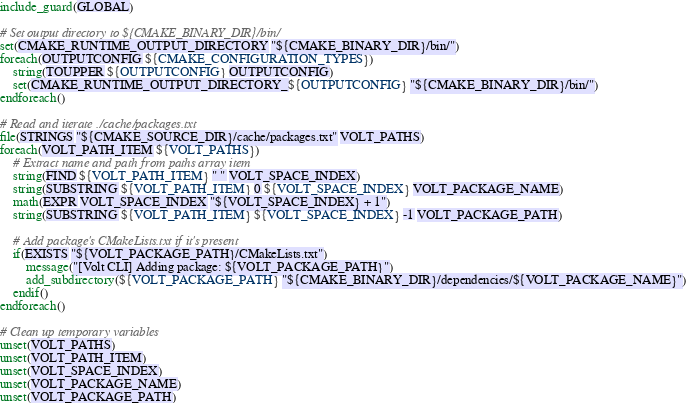<code> <loc_0><loc_0><loc_500><loc_500><_CMake_>include_guard(GLOBAL)

# Set output directory to ${CMAKE_BINARY_DIR}/bin/
set(CMAKE_RUNTIME_OUTPUT_DIRECTORY "${CMAKE_BINARY_DIR}/bin/")
foreach(OUTPUTCONFIG ${CMAKE_CONFIGURATION_TYPES})
    string(TOUPPER ${OUTPUTCONFIG} OUTPUTCONFIG)
    set(CMAKE_RUNTIME_OUTPUT_DIRECTORY_${OUTPUTCONFIG} "${CMAKE_BINARY_DIR}/bin/")
endforeach()

# Read and iterate ./cache/packages.txt
file(STRINGS "${CMAKE_SOURCE_DIR}/cache/packages.txt" VOLT_PATHS)
foreach(VOLT_PATH_ITEM ${VOLT_PATHS})
	# Extract name and path from paths array item
	string(FIND ${VOLT_PATH_ITEM} " " VOLT_SPACE_INDEX)
	string(SUBSTRING ${VOLT_PATH_ITEM} 0 ${VOLT_SPACE_INDEX} VOLT_PACKAGE_NAME)
	math(EXPR VOLT_SPACE_INDEX "${VOLT_SPACE_INDEX} + 1")
	string(SUBSTRING ${VOLT_PATH_ITEM} ${VOLT_SPACE_INDEX} -1 VOLT_PACKAGE_PATH)

	# Add package's CMakeLists.txt if it's present
	if(EXISTS "${VOLT_PACKAGE_PATH}/CMakeLists.txt")
		message("[Volt CLI] Adding package: ${VOLT_PACKAGE_PATH}")
		add_subdirectory(${VOLT_PACKAGE_PATH} "${CMAKE_BINARY_DIR}/dependencies/${VOLT_PACKAGE_NAME}")
	endif()
endforeach()

# Clean up temporary variables
unset(VOLT_PATHS)
unset(VOLT_PATH_ITEM)
unset(VOLT_SPACE_INDEX)
unset(VOLT_PACKAGE_NAME)
unset(VOLT_PACKAGE_PATH)
</code> 